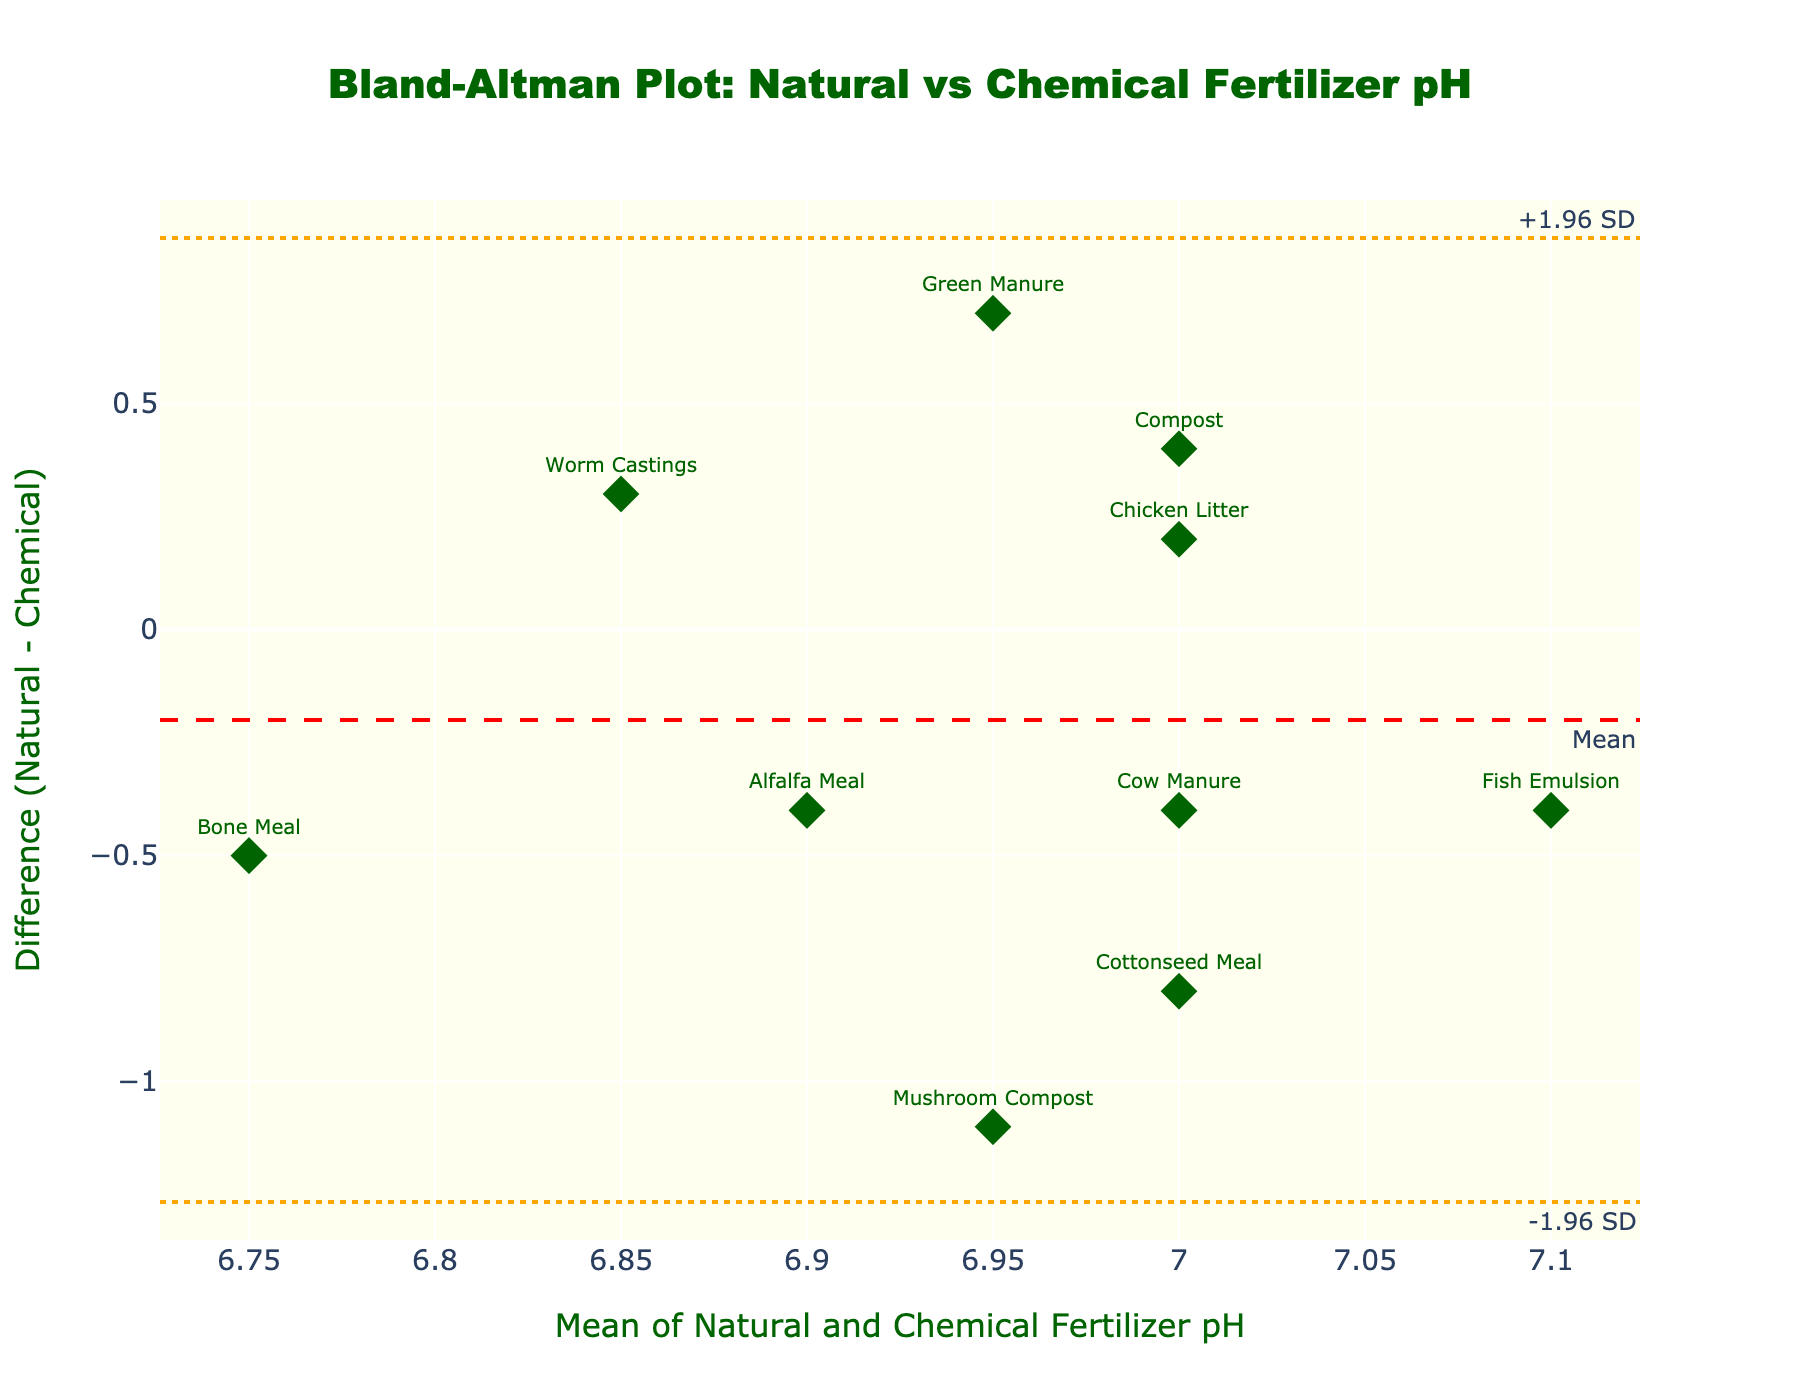What is the title of the plot? The title is the text displayed at the top of the plot, which summarizes the subject of the figure. In this case, the title is located at the top center and reads "Bland-Altman Plot: Natural vs Chemical Fertilizer pH".
Answer: Bland-Altman Plot: Natural vs Chemical Fertilizer pH How many data points are in the plot? Each data point is represented by a marker with a text label indicating the fertilizer type. By counting these markers, it is evident that there are 10 data points in the plot.
Answer: 10 Which fertilizer shows the largest positive difference in pH? The largest positive difference can be found by identifying the marker with the highest positive value on the y-axis (Difference: Natural - Chemical). The text labels help identify these markers. The data point labeled "Green Manure" is the one with the largest positive difference.
Answer: Green Manure What is the mean difference between the natural and chemical fertilizers' pH? The mean difference is displayed as a horizontal dashed line labeled "Mean" on the y-axis. The value displayed is approximately 0.01.
Answer: 0.01 Which fertilizer types lie outside the ±1.96 SD range? The ±1.96 SD range is represented by two dotted lines on the plot. By identifying the markers that fall beyond these lines, we see "Mushroom Compost" and "Green Manure" are the fertilizers outside this range.
Answer: Mushroom Compost, Green Manure On average, does natural fertilizer have a higher or lower pH compared to chemical fertilizer? By observing the mean difference line, if the line is above 0, natural fertilizer generally has a higher pH. If below 0, it has a lower pH. The mean difference line is slightly above 0, indicating natural fertilizer pH is slightly higher on average.
Answer: Higher What is the value of the upper ±1.96 SD limit for the differences? The upper ±1.96 SD limit is marked by the highest dotted orange line, annotated as "+1.96 SD". The value displayed is approximately 0.72.
Answer: 0.72 How does the pH difference for "Cow Manure" compare to the mean difference? Locate the "Cow Manure" point and check its position relative to the mean difference line. "Cow Manure" is positioned above the mean difference line, indicating its pH difference is greater than the mean difference.
Answer: Greater than What is the mean pH of the fertilizer type "Chicken Litter"? To find the mean pH, locate the "Chicken Litter" data point and observe its x-axis value, which represents the mean of natural and chemical pH. The mean pH for "Chicken Litter" is approximately 7.0.
Answer: 7.0 Which data point shows the smallest absolute difference in pH? The smallest absolute difference is found by identifying the marker closest to the y-axis (Difference: Natural - Chemical equals zero). "Bone Meal" has the smallest absolute difference in pH.
Answer: Bone Meal 